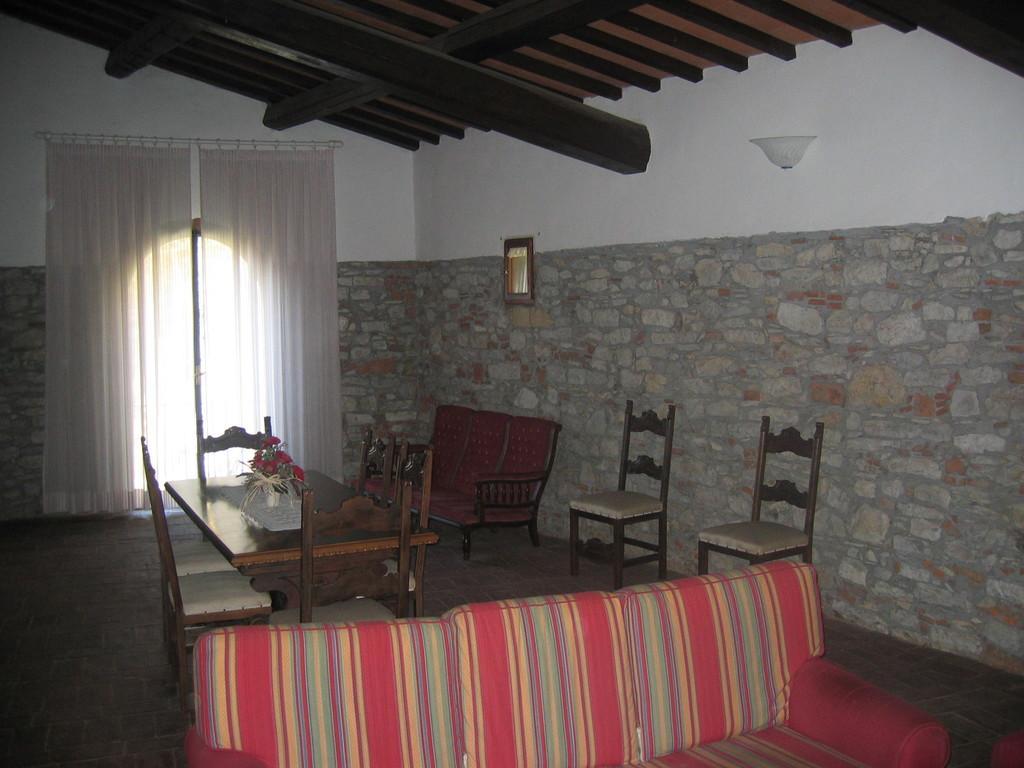Could you give a brief overview of what you see in this image? This image is taken from inside. In this image we can see there is a sofa, beside the sofa there is a table with chairs and there is a frame hanging on the wall. In the background there are curtains. At the top of the image there is a ceiling. 